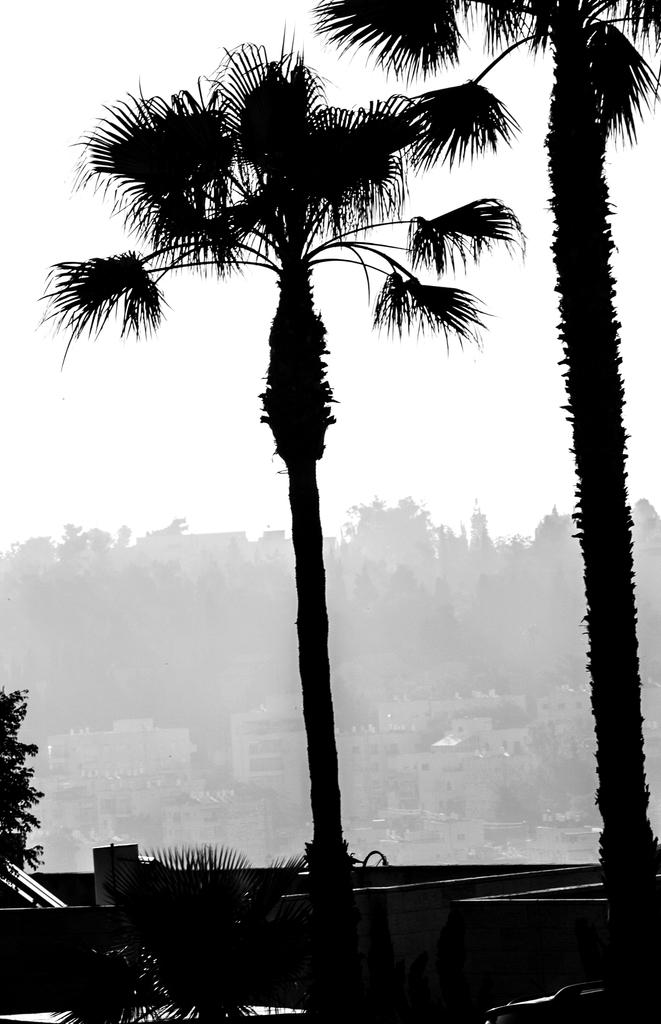What is the main subject in the center of the image? There is a tree in the center of the image. Are there any other trees visible in the image? Yes, there is a tree on the right side of the image. What can be seen in the background of the image? There are buildings, trees, and the sky visible in the background of the image. How does the cannon affect the trip in the image? There is no cannon or trip present in the image. 